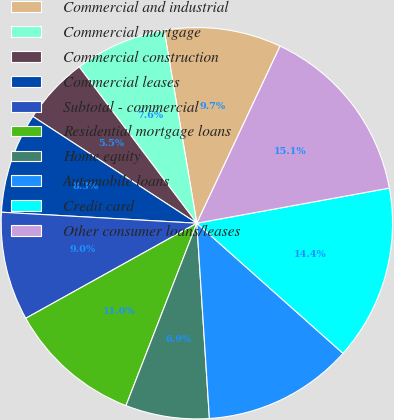Convert chart to OTSL. <chart><loc_0><loc_0><loc_500><loc_500><pie_chart><fcel>Commercial and industrial<fcel>Commercial mortgage<fcel>Commercial construction<fcel>Commercial leases<fcel>Subtotal - commercial<fcel>Residential mortgage loans<fcel>Home equity<fcel>Automobile loans<fcel>Credit card<fcel>Other consumer loans/leases<nl><fcel>9.66%<fcel>7.6%<fcel>5.55%<fcel>8.29%<fcel>8.97%<fcel>11.03%<fcel>6.92%<fcel>12.4%<fcel>14.45%<fcel>15.14%<nl></chart> 